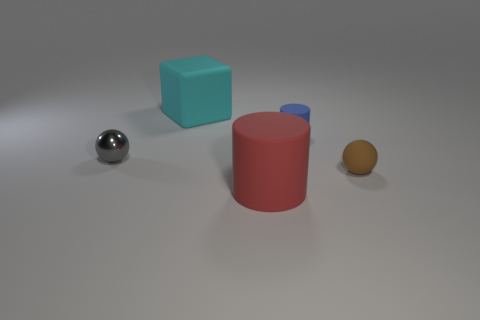Add 5 red matte cylinders. How many objects exist? 10 Subtract 1 cylinders. How many cylinders are left? 1 Subtract all green cylinders. Subtract all red balls. How many cylinders are left? 2 Subtract all blue blocks. How many green balls are left? 0 Subtract all balls. Subtract all small brown things. How many objects are left? 2 Add 5 brown rubber things. How many brown rubber things are left? 6 Add 4 shiny things. How many shiny things exist? 5 Subtract 1 gray balls. How many objects are left? 4 Subtract all cylinders. How many objects are left? 3 